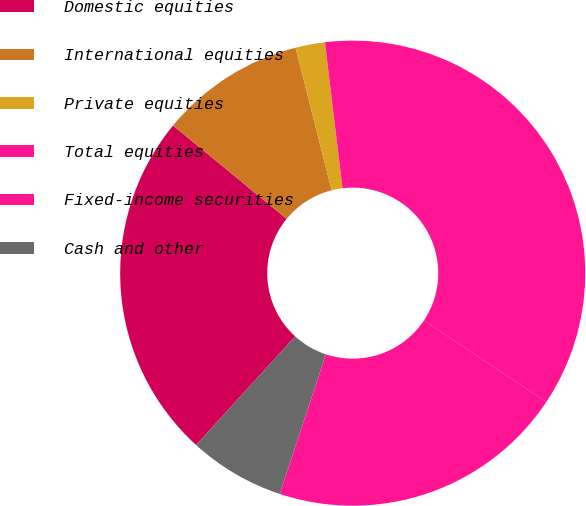<chart> <loc_0><loc_0><loc_500><loc_500><pie_chart><fcel>Domestic equities<fcel>International equities<fcel>Private equities<fcel>Total equities<fcel>Fixed-income securities<fcel>Cash and other<nl><fcel>24.19%<fcel>10.1%<fcel>2.05%<fcel>36.25%<fcel>20.75%<fcel>6.68%<nl></chart> 